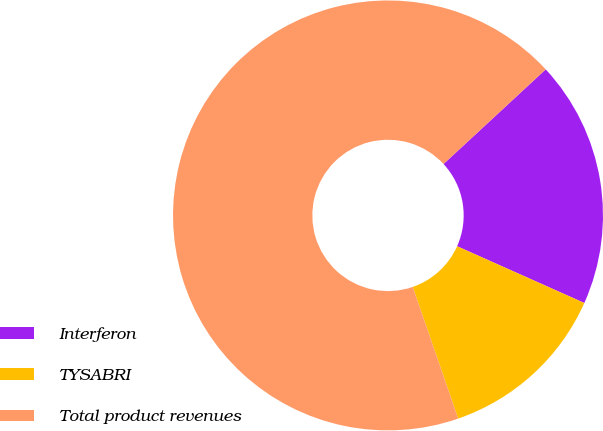Convert chart to OTSL. <chart><loc_0><loc_0><loc_500><loc_500><pie_chart><fcel>Interferon<fcel>TYSABRI<fcel>Total product revenues<nl><fcel>18.57%<fcel>13.03%<fcel>68.4%<nl></chart> 